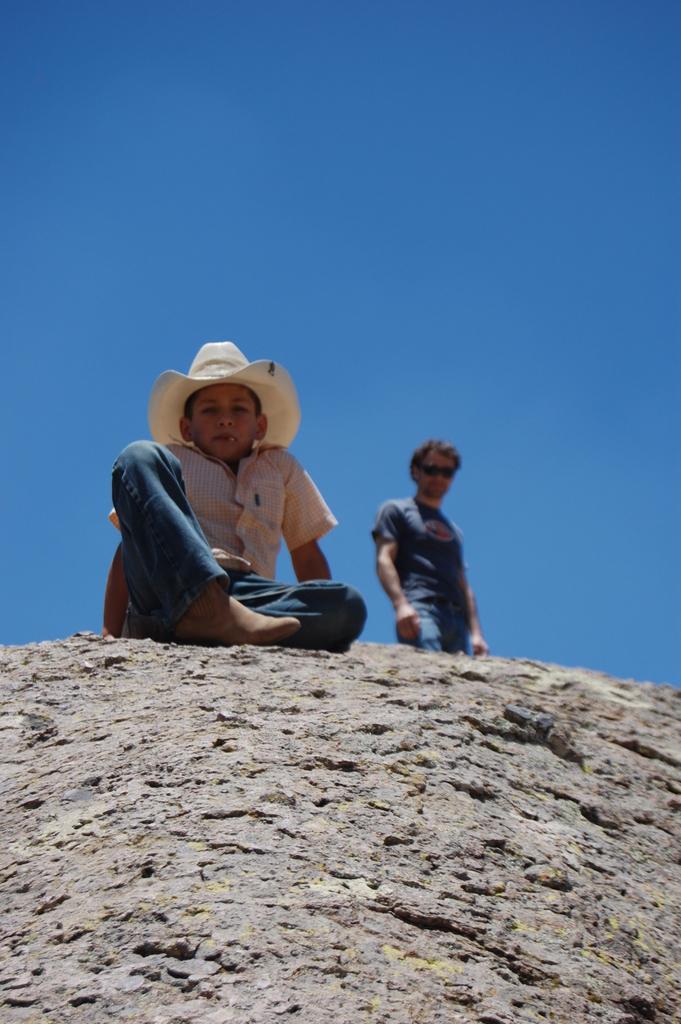Could you give a brief overview of what you see in this image? In this picture we can see a person standing and a kid sitting here, this kid wore a cap, we can see the sky at the top of the picture. 